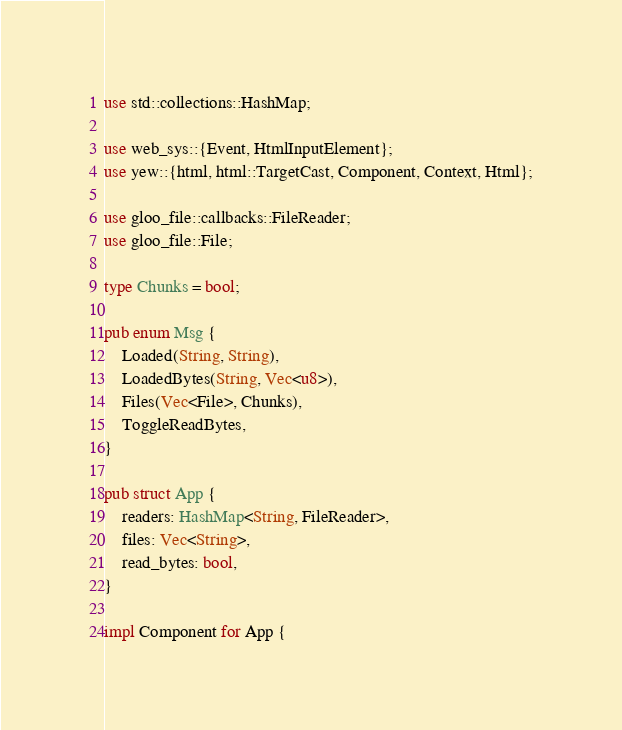<code> <loc_0><loc_0><loc_500><loc_500><_Rust_>use std::collections::HashMap;

use web_sys::{Event, HtmlInputElement};
use yew::{html, html::TargetCast, Component, Context, Html};

use gloo_file::callbacks::FileReader;
use gloo_file::File;

type Chunks = bool;

pub enum Msg {
    Loaded(String, String),
    LoadedBytes(String, Vec<u8>),
    Files(Vec<File>, Chunks),
    ToggleReadBytes,
}

pub struct App {
    readers: HashMap<String, FileReader>,
    files: Vec<String>,
    read_bytes: bool,
}

impl Component for App {</code> 